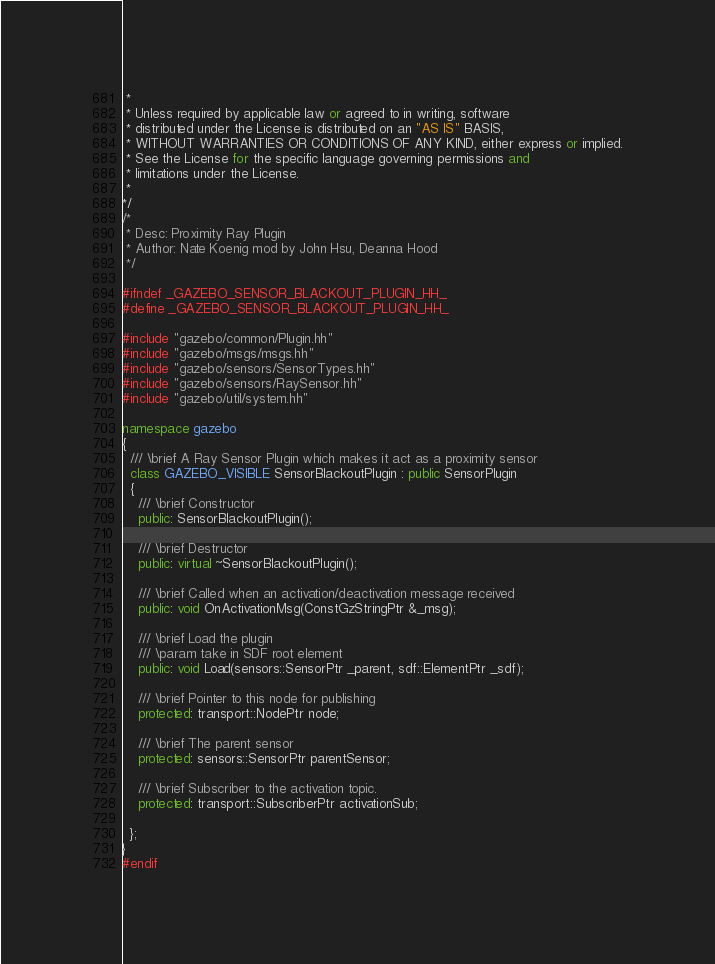Convert code to text. <code><loc_0><loc_0><loc_500><loc_500><_C++_> *
 * Unless required by applicable law or agreed to in writing, software
 * distributed under the License is distributed on an "AS IS" BASIS,
 * WITHOUT WARRANTIES OR CONDITIONS OF ANY KIND, either express or implied.
 * See the License for the specific language governing permissions and
 * limitations under the License.
 *
*/
/*
 * Desc: Proximity Ray Plugin
 * Author: Nate Koenig mod by John Hsu, Deanna Hood
 */

#ifndef _GAZEBO_SENSOR_BLACKOUT_PLUGIN_HH_
#define _GAZEBO_SENSOR_BLACKOUT_PLUGIN_HH_

#include "gazebo/common/Plugin.hh"
#include "gazebo/msgs/msgs.hh"
#include "gazebo/sensors/SensorTypes.hh"
#include "gazebo/sensors/RaySensor.hh"
#include "gazebo/util/system.hh"

namespace gazebo
{
  /// \brief A Ray Sensor Plugin which makes it act as a proximity sensor
  class GAZEBO_VISIBLE SensorBlackoutPlugin : public SensorPlugin
  {
    /// \brief Constructor
    public: SensorBlackoutPlugin();

    /// \brief Destructor
    public: virtual ~SensorBlackoutPlugin();

    /// \brief Called when an activation/deactivation message received
    public: void OnActivationMsg(ConstGzStringPtr &_msg);

    /// \brief Load the plugin
    /// \param take in SDF root element
    public: void Load(sensors::SensorPtr _parent, sdf::ElementPtr _sdf);

    /// \brief Pointer to this node for publishing
    protected: transport::NodePtr node;

    /// \brief The parent sensor
    protected: sensors::SensorPtr parentSensor;

    /// \brief Subscriber to the activation topic.
    protected: transport::SubscriberPtr activationSub;

  };
}
#endif
</code> 